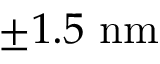Convert formula to latex. <formula><loc_0><loc_0><loc_500><loc_500>\pm 1 . 5 \ n m</formula> 